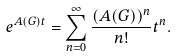<formula> <loc_0><loc_0><loc_500><loc_500>e ^ { A ( G ) t } = \sum _ { n = 0 } ^ { \infty } \frac { ( A ( G ) ) ^ { n } } { n ! } t ^ { n } .</formula> 